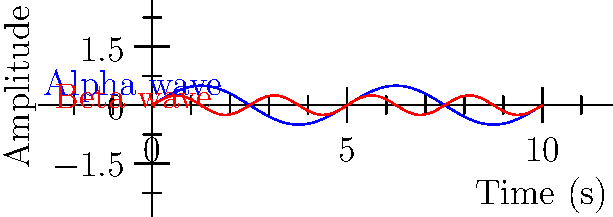In a study on mental disorders and addictive behaviors, you're analyzing brain wave patterns. The graph shows two sine waves representing alpha and beta brain wave frequencies. The blue curve represents alpha waves with a maximum amplitude of 0.5 and a period of 5 seconds. The red curve represents beta waves with a maximum amplitude of 0.25. If the beta wave completes 4 cycles in 10 seconds, what is the phase difference (in radians) between the alpha and beta waves at $t = 2.5$ seconds? Let's approach this step-by-step:

1) First, we need to determine the angular frequencies ($\omega$) for both waves:

   For alpha waves: $\omega_\alpha = \frac{2\pi}{T_\alpha} = \frac{2\pi}{5} = 0.4\pi$ rad/s
   For beta waves: $\omega_\beta = \frac{2\pi}{T_\beta} = \frac{2\pi}{2.5} = 0.8\pi$ rad/s

2) The general equation for a sine wave is $y = A \sin(\omega t + \phi)$, where $\phi$ is the phase shift.

3) At $t = 2.5$ seconds, the phase of each wave will be:

   Alpha: $\omega_\alpha t = 0.4\pi \cdot 2.5 = \pi$ rad
   Beta: $\omega_\beta t = 0.8\pi \cdot 2.5 = 2\pi$ rad

4) The phase difference is the difference between these phases:

   $\Delta \phi = 2\pi - \pi = \pi$ rad

Therefore, at $t = 2.5$ seconds, the phase difference between the alpha and beta waves is $\pi$ radians.
Answer: $\pi$ radians 